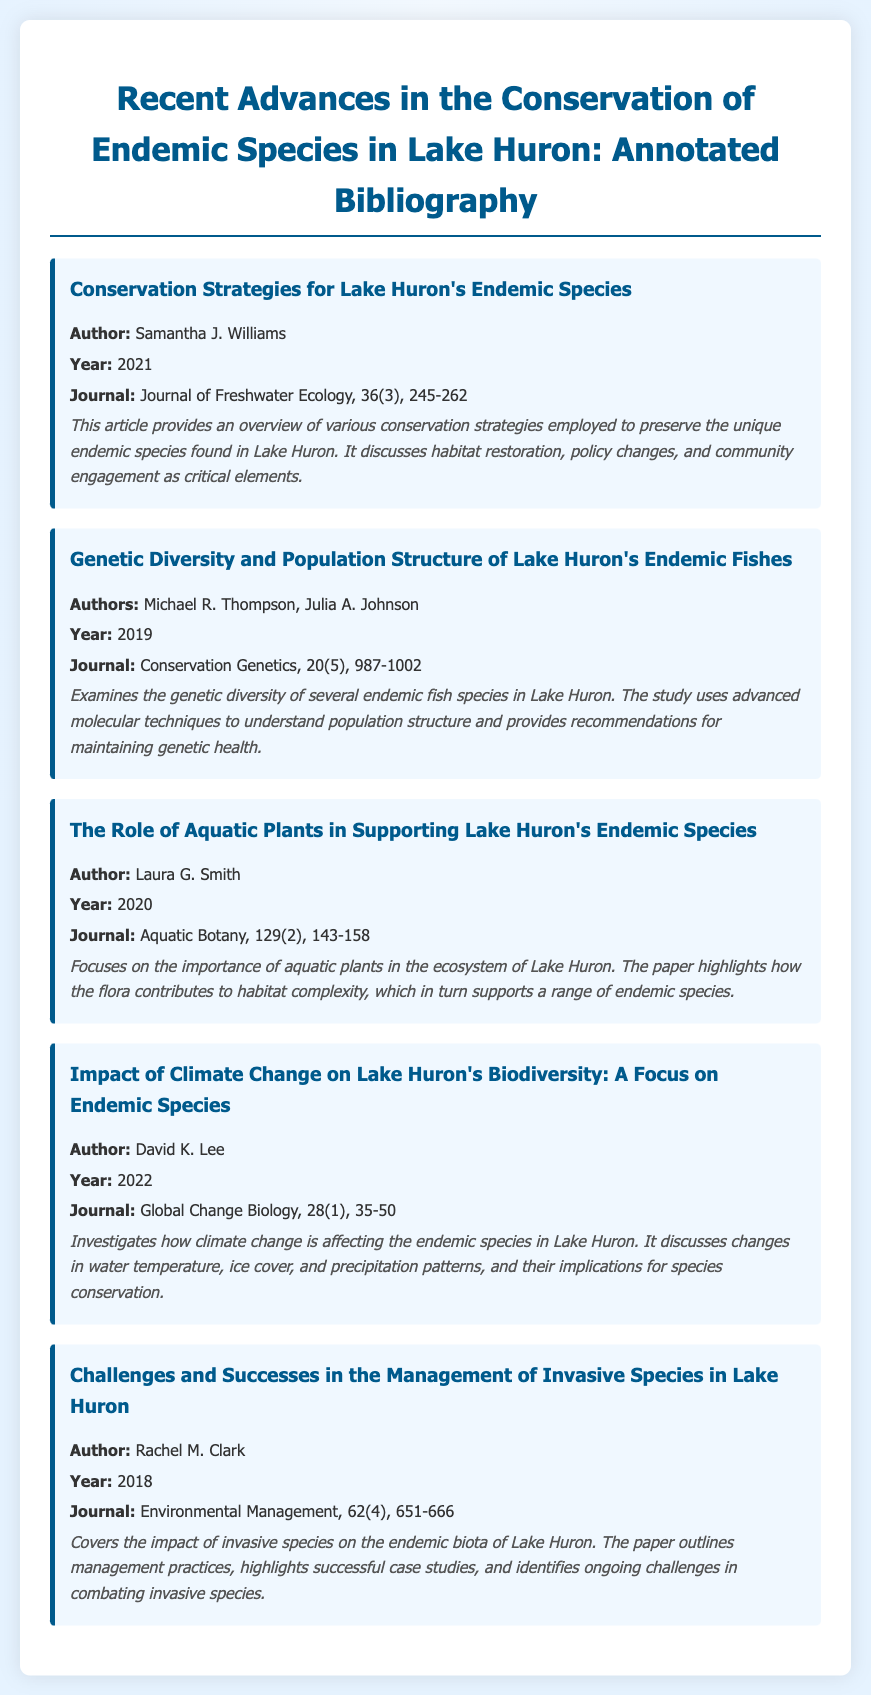What is the title of the first bibliography item? The title is the heading of the first bibliography entry and provides insight into its content, which is about conservation strategies.
Answer: Conservation Strategies for Lake Huron's Endemic Species Who authored the article on genetic diversity? The author's names are listed directly under the title in the bibliography item regarding genetic diversity.
Answer: Michael R. Thompson, Julia A. Johnson In what year was the article about aquatic plants published? The publication year is indicated in the bibliography entry for the respective article focused on aquatic plants.
Answer: 2020 What is a major theme discussed in David K. Lee's article? The main subject of David K. Lee's article is highlighted in its summary as it investigates the impact of climate change on biodiversity.
Answer: Climate change How many pages does Rachel M. Clark's article span? The specific journal page range for Rachel M. Clark's article is directly mentioned in its bibliography entry.
Answer: 651-666 